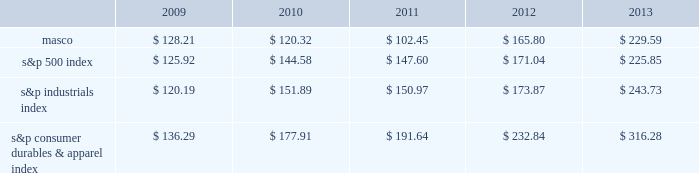6feb201418202649 performance graph the table below compares the cumulative total shareholder return on our common stock with the cumulative total return of ( i ) the standard & poor 2019s 500 composite stock index ( 2018 2018s&p 500 index 2019 2019 ) , ( ii ) the standard & poor 2019s industrials index ( 2018 2018s&p industrials index 2019 2019 ) and ( iii ) the standard & poor 2019s consumer durables & apparel index ( 2018 2018s&p consumer durables & apparel index 2019 2019 ) , from december 31 , 2008 through december 31 , 2013 , when the closing price of our common stock was $ 22.77 .
The graph assumes investments of $ 100 on december 31 , 2008 in our common stock and in each of the three indices and the reinvestment of dividends .
$ 350.00 $ 300.00 $ 250.00 $ 200.00 $ 150.00 $ 100.00 $ 50.00 performance graph .
In july 2007 , our board of directors authorized the purchase of up to 50 million shares of our common stock in open-market transactions or otherwise .
At december 31 , 2013 , we had remaining authorization to repurchase up to 22.6 million shares .
During the first quarter of 2013 , we repurchased and retired 1.7 million shares of our common stock , for cash aggregating $ 35 million to offset the dilutive impact of the 2013 grant of 1.7 million shares of long-term stock awards .
We have not purchased any shares since march 2013. .
What was the difference in percentage cumulative total shareholder return on masco common stock versus the s&p 500 index for the five year period ended 2013? 
Computations: (((229.59 - 100) / 100) - ((225.85 - 100) / 100))
Answer: 0.0374. 